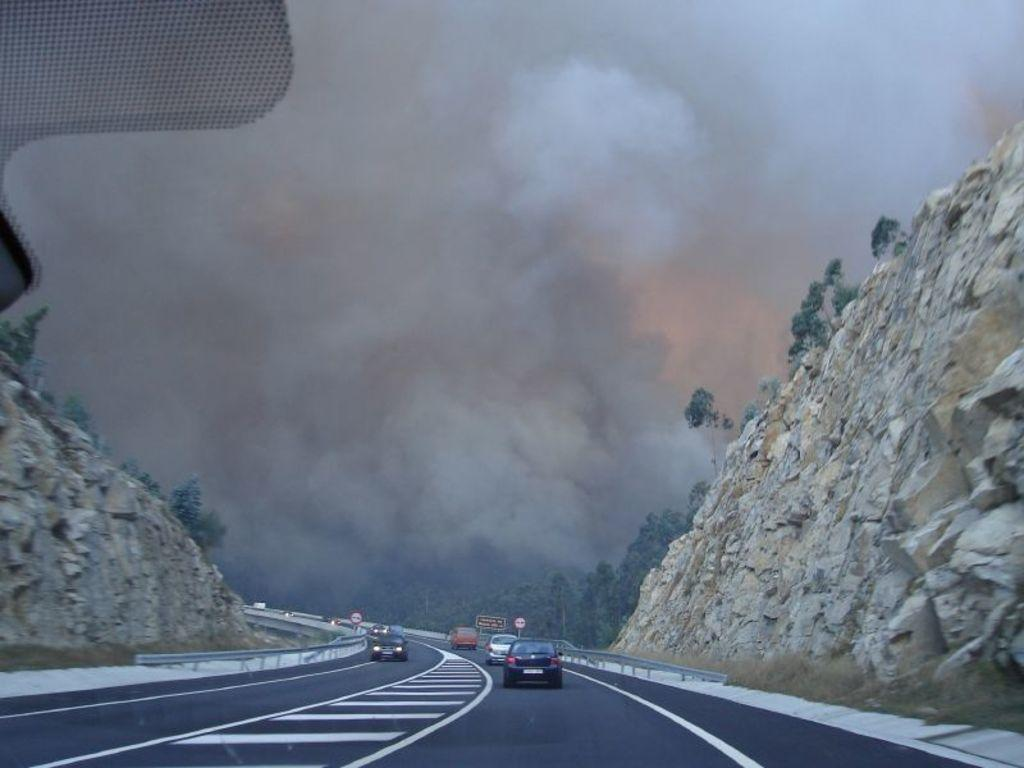What can be seen on the road in the image? There are cars parked on the road in the image. What surrounds the road in the image? There are rock hills on both sides of the road in the image. What type of vegetation is visible in the background of the image? There are many trees visible in the background of the image. What is the condition of the sky in the image? The sky is clear in the image. How does the girl in the image contribute to the wealth of the community? There is no girl present in the image, so it is not possible to determine her contribution to the community's wealth. 